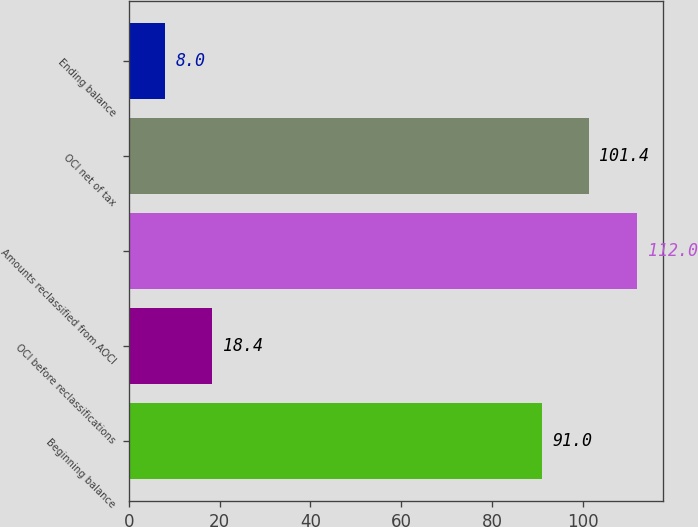Convert chart. <chart><loc_0><loc_0><loc_500><loc_500><bar_chart><fcel>Beginning balance<fcel>OCI before reclassifications<fcel>Amounts reclassified from AOCI<fcel>OCI net of tax<fcel>Ending balance<nl><fcel>91<fcel>18.4<fcel>112<fcel>101.4<fcel>8<nl></chart> 